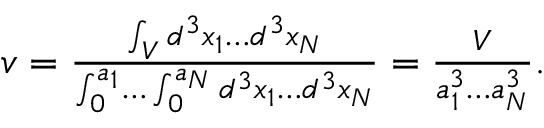<formula> <loc_0><loc_0><loc_500><loc_500>\begin{array} { r } { v = { { \frac { \int _ { V } d ^ { 3 } x _ { 1 } d ^ { 3 } x _ { N } } { \int _ { 0 } ^ { a _ { 1 } } \int _ { 0 } ^ { a _ { N } } d ^ { 3 } x _ { 1 } d ^ { 3 } x _ { N } } } } = { \frac { V } { a _ { 1 } ^ { 3 } a _ { N } ^ { 3 } } } . } \end{array}</formula> 